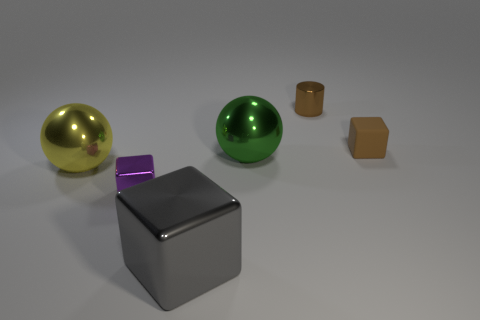There is a block that is both on the left side of the tiny brown shiny cylinder and on the right side of the purple block; what material is it?
Your response must be concise. Metal. Is the large cube made of the same material as the purple cube right of the yellow thing?
Your answer should be compact. Yes. How many objects are brown cylinders or metal things that are in front of the tiny metallic cylinder?
Provide a short and direct response. 5. Is the size of the thing to the right of the tiny brown cylinder the same as the cube on the left side of the big metal block?
Keep it short and to the point. Yes. How many other things are the same color as the rubber thing?
Make the answer very short. 1. Does the purple thing have the same size as the brown thing that is in front of the tiny brown metallic thing?
Provide a succinct answer. Yes. How big is the block that is in front of the tiny metallic thing in front of the tiny brown block?
Provide a succinct answer. Large. What color is the other metallic object that is the same shape as the gray metal object?
Make the answer very short. Purple. Does the green thing have the same size as the brown matte cube?
Provide a succinct answer. No. Are there the same number of small brown matte things behind the metal cylinder and big brown matte cubes?
Ensure brevity in your answer.  Yes. 